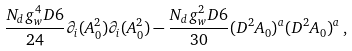Convert formula to latex. <formula><loc_0><loc_0><loc_500><loc_500>\frac { N _ { d } g _ { w } ^ { 4 } D 6 } { 2 4 } \partial _ { i } ( A _ { 0 } ^ { 2 } ) \partial _ { i } ( A _ { 0 } ^ { 2 } ) - \frac { N _ { d } g _ { w } ^ { 2 } D 6 } { 3 0 } ( D ^ { 2 } A _ { 0 } ) ^ { a } ( D ^ { 2 } A _ { 0 } ) ^ { a } \, ,</formula> 